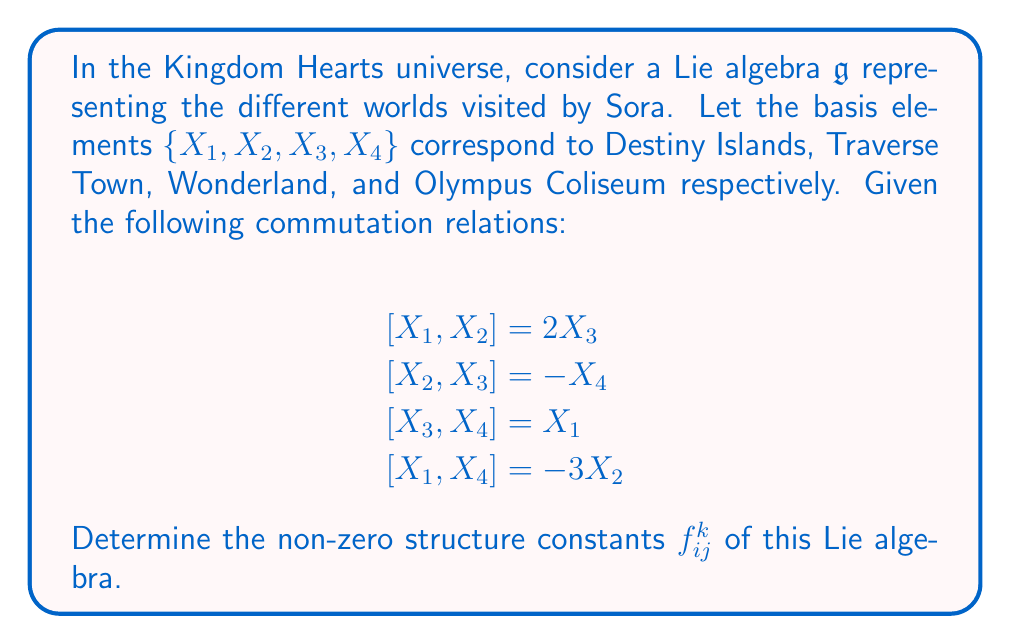What is the answer to this math problem? To solve this problem, we need to understand the concept of structure constants in Lie algebras and how they relate to the commutation relations given.

1) In a Lie algebra, the structure constants $f_{ij}^k$ are defined by the equation:

   $$[X_i, X_j] = \sum_k f_{ij}^k X_k$$

2) We can identify the structure constants by comparing this general form with the given commutation relations.

3) From $[X_1, X_2] = 2X_3$:
   - $f_{12}^3 = 2$ (and $f_{21}^3 = -2$ due to antisymmetry)

4) From $[X_2, X_3] = -X_4$:
   - $f_{23}^4 = -1$ (and $f_{32}^4 = 1$)

5) From $[X_3, X_4] = X_1$:
   - $f_{34}^1 = 1$ (and $f_{43}^1 = -1$)

6) From $[X_1, X_4] = -3X_2$:
   - $f_{14}^2 = -3$ (and $f_{41}^2 = 3$)

7) All other structure constants are zero.

Note: The structure constants are antisymmetric in the lower indices, i.e., $f_{ij}^k = -f_{ji}^k$.
Answer: The non-zero structure constants are:

$f_{12}^3 = 2$, $f_{21}^3 = -2$
$f_{23}^4 = -1$, $f_{32}^4 = 1$
$f_{34}^1 = 1$, $f_{43}^1 = -1$
$f_{14}^2 = -3$, $f_{41}^2 = 3$ 